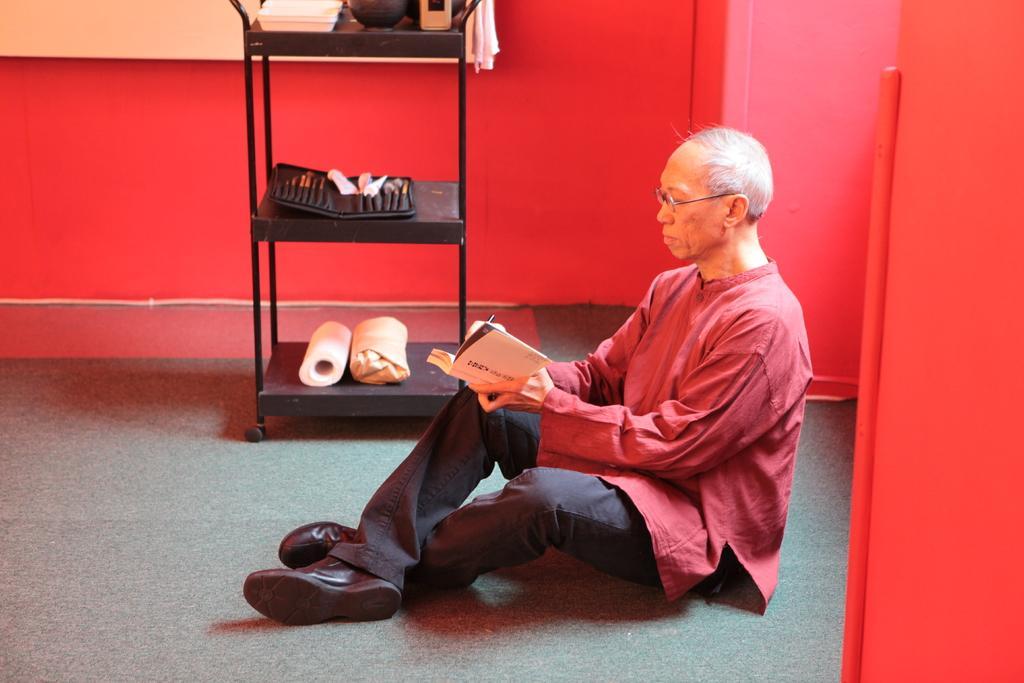Please provide a concise description of this image. In this image there is one person who is sitting, and he is holding a book and writing something. And in the background there is a table, and on the table there are some mats and some objects and there is a wall which is in red color. At the bottom there is a floor. 